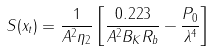<formula> <loc_0><loc_0><loc_500><loc_500>S ( x _ { t } ) = \frac { 1 } { A ^ { 2 } \eta _ { 2 } } \left [ \frac { 0 . 2 2 3 } { A ^ { 2 } B _ { K } R _ { b } } - \frac { P _ { 0 } } { \lambda ^ { 4 } } \right ]</formula> 